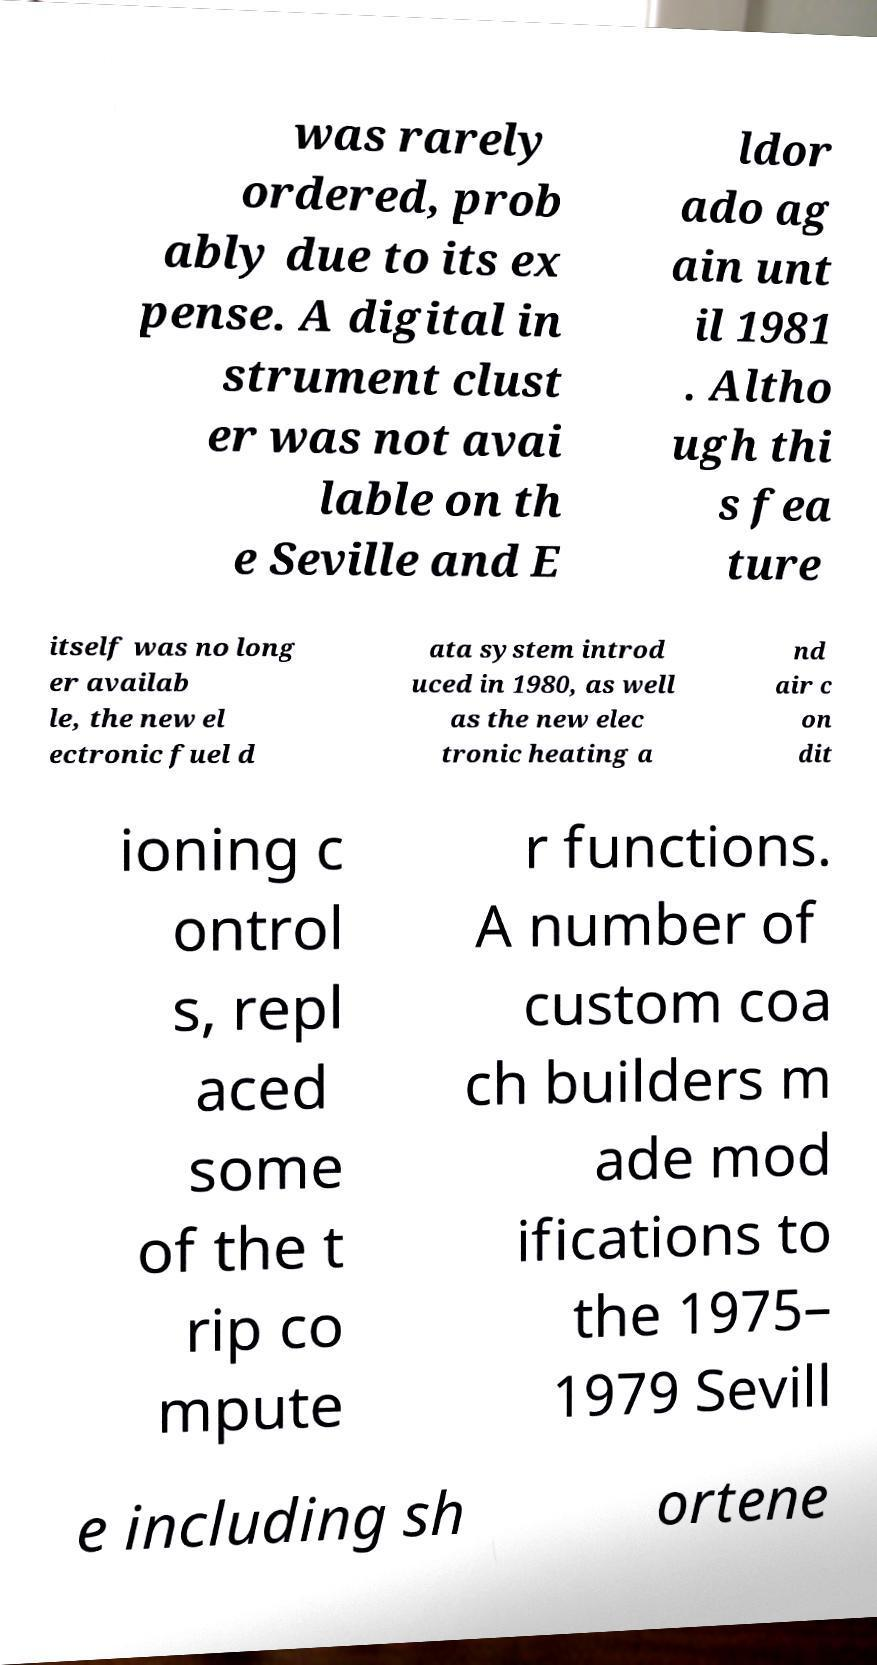Please identify and transcribe the text found in this image. was rarely ordered, prob ably due to its ex pense. A digital in strument clust er was not avai lable on th e Seville and E ldor ado ag ain unt il 1981 . Altho ugh thi s fea ture itself was no long er availab le, the new el ectronic fuel d ata system introd uced in 1980, as well as the new elec tronic heating a nd air c on dit ioning c ontrol s, repl aced some of the t rip co mpute r functions. A number of custom coa ch builders m ade mod ifications to the 1975– 1979 Sevill e including sh ortene 